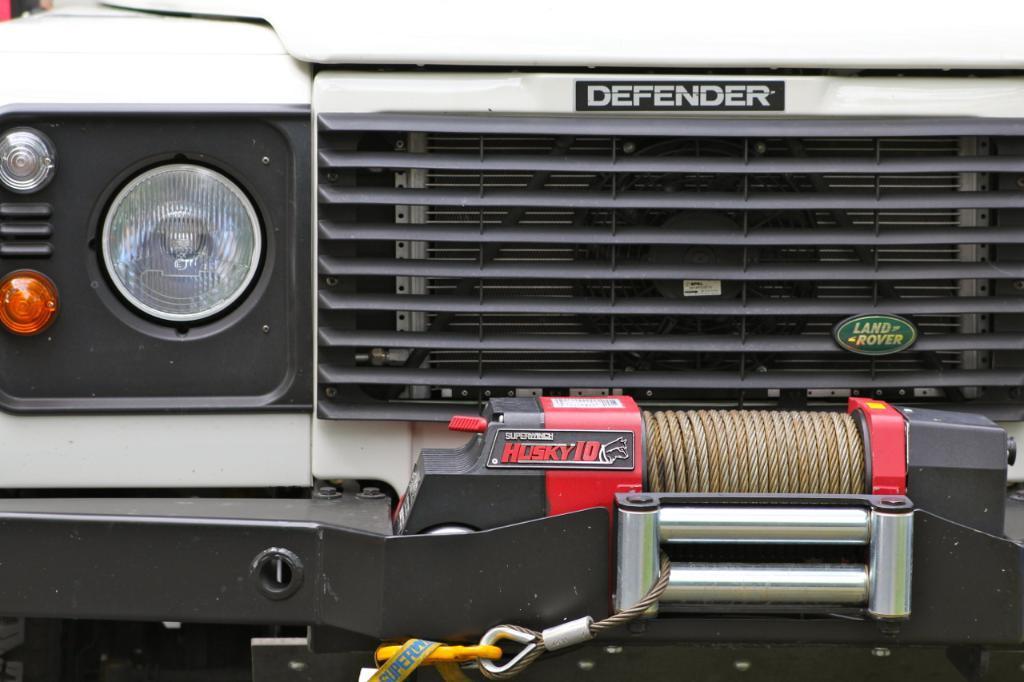Can you describe this image briefly? A picture of a vehicle. To this vehicle there are boards, headlights, rope and rods. Something written on these boards. 